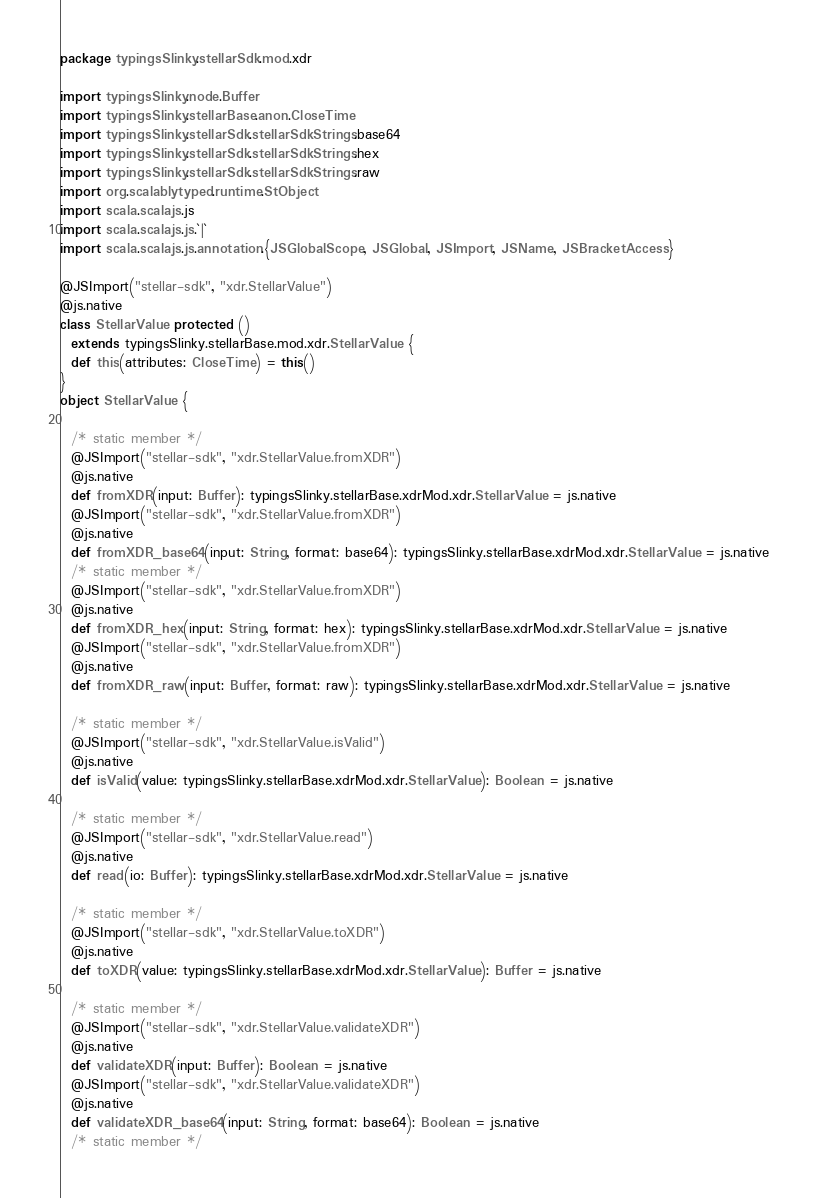<code> <loc_0><loc_0><loc_500><loc_500><_Scala_>package typingsSlinky.stellarSdk.mod.xdr

import typingsSlinky.node.Buffer
import typingsSlinky.stellarBase.anon.CloseTime
import typingsSlinky.stellarSdk.stellarSdkStrings.base64
import typingsSlinky.stellarSdk.stellarSdkStrings.hex
import typingsSlinky.stellarSdk.stellarSdkStrings.raw
import org.scalablytyped.runtime.StObject
import scala.scalajs.js
import scala.scalajs.js.`|`
import scala.scalajs.js.annotation.{JSGlobalScope, JSGlobal, JSImport, JSName, JSBracketAccess}

@JSImport("stellar-sdk", "xdr.StellarValue")
@js.native
class StellarValue protected ()
  extends typingsSlinky.stellarBase.mod.xdr.StellarValue {
  def this(attributes: CloseTime) = this()
}
object StellarValue {
  
  /* static member */
  @JSImport("stellar-sdk", "xdr.StellarValue.fromXDR")
  @js.native
  def fromXDR(input: Buffer): typingsSlinky.stellarBase.xdrMod.xdr.StellarValue = js.native
  @JSImport("stellar-sdk", "xdr.StellarValue.fromXDR")
  @js.native
  def fromXDR_base64(input: String, format: base64): typingsSlinky.stellarBase.xdrMod.xdr.StellarValue = js.native
  /* static member */
  @JSImport("stellar-sdk", "xdr.StellarValue.fromXDR")
  @js.native
  def fromXDR_hex(input: String, format: hex): typingsSlinky.stellarBase.xdrMod.xdr.StellarValue = js.native
  @JSImport("stellar-sdk", "xdr.StellarValue.fromXDR")
  @js.native
  def fromXDR_raw(input: Buffer, format: raw): typingsSlinky.stellarBase.xdrMod.xdr.StellarValue = js.native
  
  /* static member */
  @JSImport("stellar-sdk", "xdr.StellarValue.isValid")
  @js.native
  def isValid(value: typingsSlinky.stellarBase.xdrMod.xdr.StellarValue): Boolean = js.native
  
  /* static member */
  @JSImport("stellar-sdk", "xdr.StellarValue.read")
  @js.native
  def read(io: Buffer): typingsSlinky.stellarBase.xdrMod.xdr.StellarValue = js.native
  
  /* static member */
  @JSImport("stellar-sdk", "xdr.StellarValue.toXDR")
  @js.native
  def toXDR(value: typingsSlinky.stellarBase.xdrMod.xdr.StellarValue): Buffer = js.native
  
  /* static member */
  @JSImport("stellar-sdk", "xdr.StellarValue.validateXDR")
  @js.native
  def validateXDR(input: Buffer): Boolean = js.native
  @JSImport("stellar-sdk", "xdr.StellarValue.validateXDR")
  @js.native
  def validateXDR_base64(input: String, format: base64): Boolean = js.native
  /* static member */</code> 